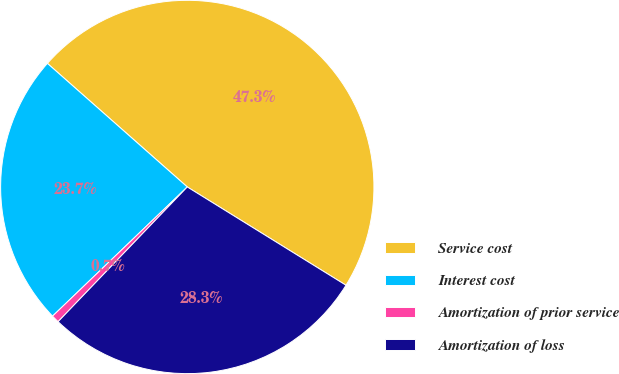Convert chart to OTSL. <chart><loc_0><loc_0><loc_500><loc_500><pie_chart><fcel>Service cost<fcel>Interest cost<fcel>Amortization of prior service<fcel>Amortization of loss<nl><fcel>47.31%<fcel>23.68%<fcel>0.67%<fcel>28.34%<nl></chart> 